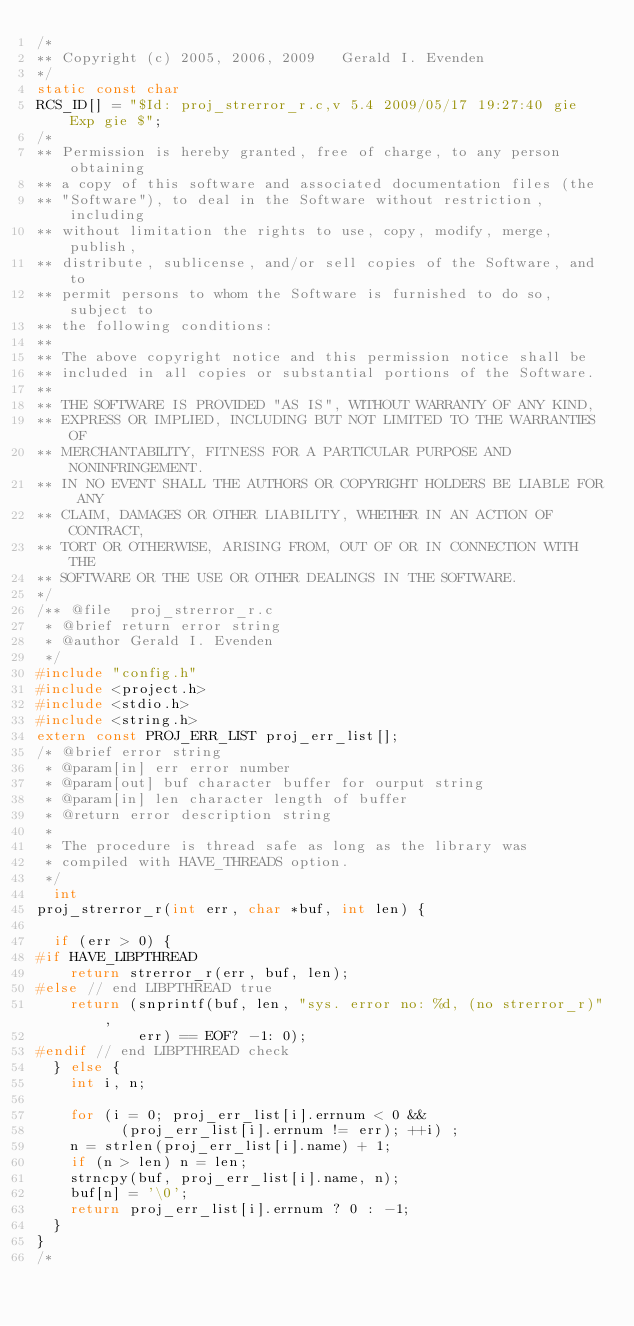<code> <loc_0><loc_0><loc_500><loc_500><_C_>/*
** Copyright (c) 2005, 2006, 2009   Gerald I. Evenden
*/
static const char
RCS_ID[] = "$Id: proj_strerror_r.c,v 5.4 2009/05/17 19:27:40 gie Exp gie $";
/*
** Permission is hereby granted, free of charge, to any person obtaining
** a copy of this software and associated documentation files (the
** "Software"), to deal in the Software without restriction, including
** without limitation the rights to use, copy, modify, merge, publish,
** distribute, sublicense, and/or sell copies of the Software, and to
** permit persons to whom the Software is furnished to do so, subject to
** the following conditions:
**
** The above copyright notice and this permission notice shall be
** included in all copies or substantial portions of the Software.
**
** THE SOFTWARE IS PROVIDED "AS IS", WITHOUT WARRANTY OF ANY KIND,
** EXPRESS OR IMPLIED, INCLUDING BUT NOT LIMITED TO THE WARRANTIES OF
** MERCHANTABILITY, FITNESS FOR A PARTICULAR PURPOSE AND NONINFRINGEMENT.
** IN NO EVENT SHALL THE AUTHORS OR COPYRIGHT HOLDERS BE LIABLE FOR ANY
** CLAIM, DAMAGES OR OTHER LIABILITY, WHETHER IN AN ACTION OF CONTRACT,
** TORT OR OTHERWISE, ARISING FROM, OUT OF OR IN CONNECTION WITH THE
** SOFTWARE OR THE USE OR OTHER DEALINGS IN THE SOFTWARE.
*/
/** @file  proj_strerror_r.c
 * @brief return error string
 * @author Gerald I. Evenden
 */
#include "config.h"
#include <project.h>
#include <stdio.h>
#include <string.h>
extern const PROJ_ERR_LIST proj_err_list[];
/* @brief error string
 * @param[in] err error number
 * @param[out] buf character buffer for ourput string
 * @param[in] len character length of buffer
 * @return error description string
 *
 * The procedure is thread safe as long as the library was
 * compiled with HAVE_THREADS option.
 */
	int
proj_strerror_r(int err, char *buf, int len) {
		
	if (err > 0) {
#if HAVE_LIBPTHREAD
		return strerror_r(err, buf, len);
#else // end LIBPTHREAD true
		return (snprintf(buf, len, "sys. error no: %d, (no strerror_r)",
						err) == EOF? -1: 0);
#endif // end LIBPTHREAD check
	} else {
		int i, n;

		for (i = 0; proj_err_list[i].errnum < 0 &&
					(proj_err_list[i].errnum != err); ++i) ;
		n = strlen(proj_err_list[i].name) + 1;
		if (n > len) n = len;
		strncpy(buf, proj_err_list[i].name, n);
		buf[n] = '\0';
		return proj_err_list[i].errnum ? 0 : -1;
	}
}
/*</code> 